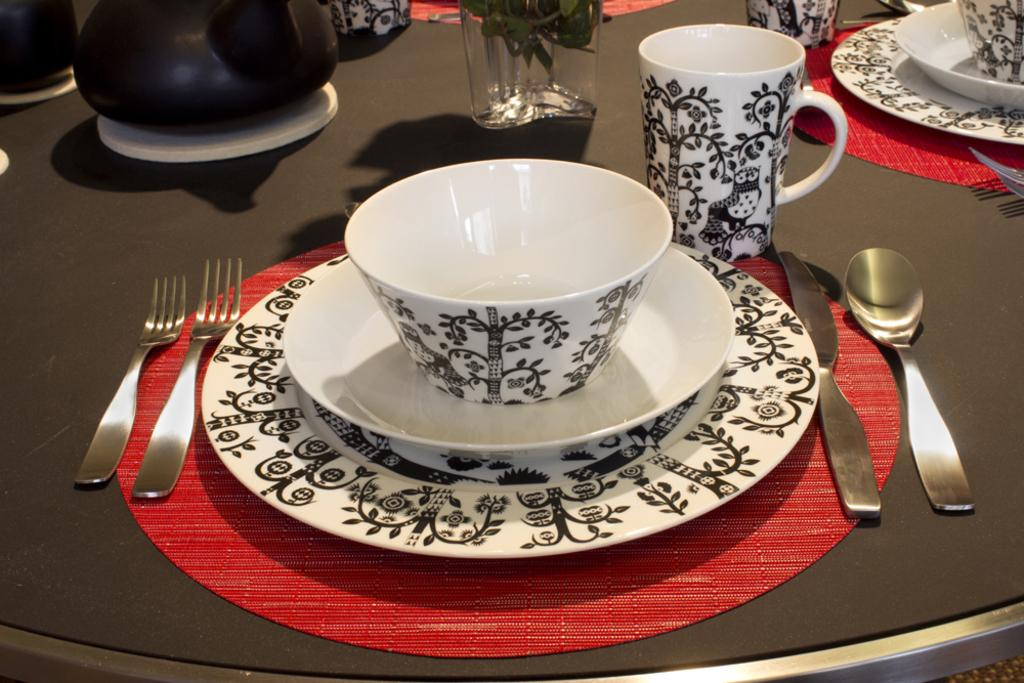What type of dishware can be seen in the image? There is a cup, saucer, plate, and glass in the image. What utensils are present in the image? There are 2 forks, a knife, and a spoon in the image. What other objects can be seen on the table? There is a table mat, a small plant, and a teapot in the image. How are these objects arranged on the table? All these objects are arranged in an order on a table. How many rings are visible on the table in the image? There are no rings present in the image. Can you describe the coat that is hanging on the chair in the image? There is no coat present in the image. 